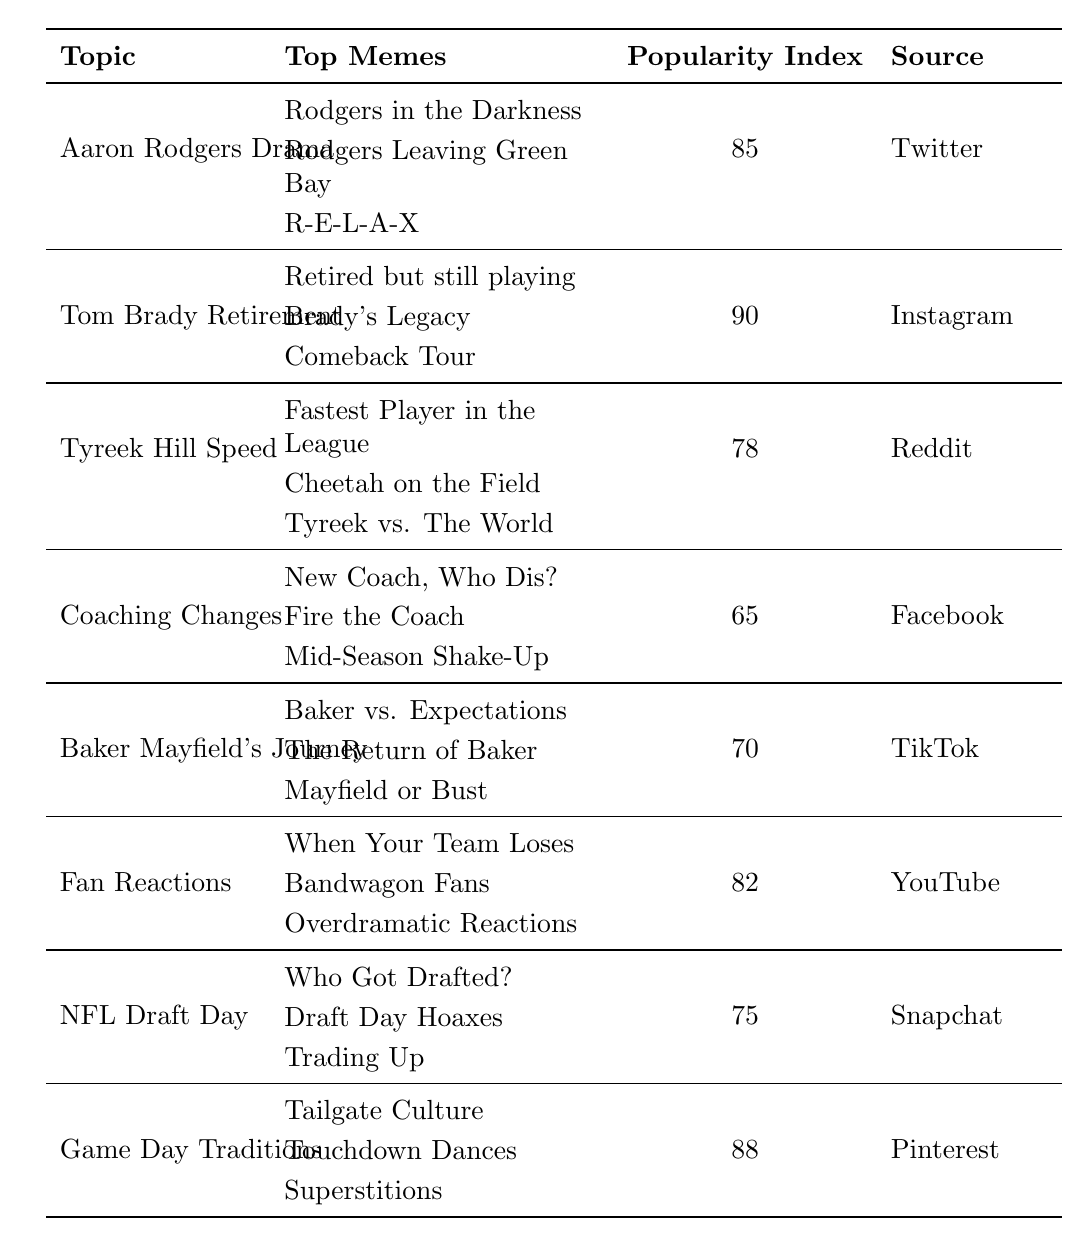What is the popularity index of the topic "Game Day Traditions"? The popularity index is explicitly stated in the table under the topic "Game Day Traditions," which shows a value of 88.
Answer: 88 Which source has the highest popularity index among the meme topics? By comparing the popularity indices in the table, "Tom Brady Retirement" has the highest index at 90, which is higher than all other topics.
Answer: Instagram How many topics have a popularity index greater than 80? Counting the topics with indices greater than 80, we find "Tom Brady Retirement" (90), "Game Day Traditions" (88), "Aaron Rodgers Drama" (85), and "Fan Reactions" (82), totaling 4 topics.
Answer: 4 Is "Baker Mayfield's Journey" more popular than "Coaching Changes"? Comparing the popularity indices, "Baker Mayfield's Journey" has an index of 70, while "Coaching Changes" has an index of 65. Since 70 is greater than 65, the answer is yes.
Answer: Yes Which topic has the least popularity index and what is it? The popularity indices for each topic are compared, and "Coaching Changes" is found to have the least index at 65 among all topics listed.
Answer: Coaching Changes, 65 What is the average popularity index of all the meme topics listed? To find the average, sum the popularity indices: 85 + 90 + 78 + 65 + 70 + 82 + 75 + 88 =  633. There are 8 topics, so the average is 633/8 = 79.125, which rounds to approximately 79.
Answer: 79 Which meme related to Tyreek Hill Speed is the most popular? The table lists "Fastest Player in the League," "Cheetah on the Field," and "Tyreek vs. The World" as top memes under "Tyreek Hill Speed." Without numerical values to denote popularity among these memes, we can't draw a definitive conclusion.
Answer: Cannot be determined without further data If you combine the popularity indices of "Fan Reactions" and "NFL Draft Day," what is the result? The popularity index for "Fan Reactions" is 82, and for "NFL Draft Day," it is 75. Adding these gives 82 + 75 = 157.
Answer: 157 